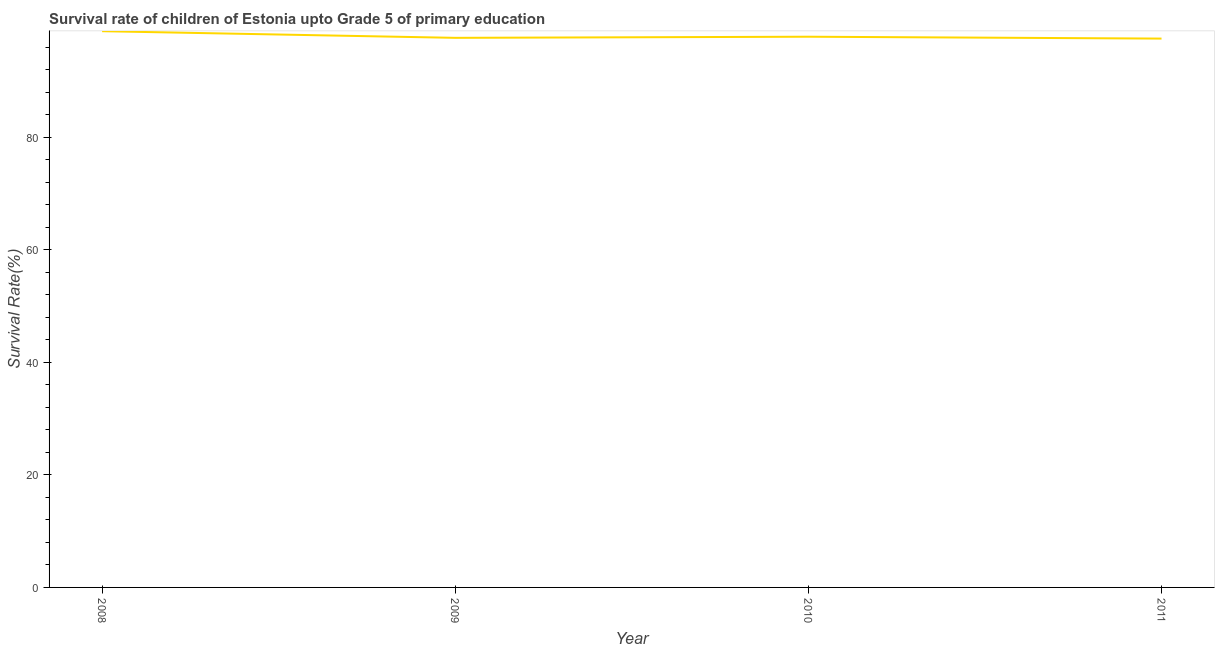What is the survival rate in 2010?
Give a very brief answer. 97.85. Across all years, what is the maximum survival rate?
Your answer should be compact. 98.83. Across all years, what is the minimum survival rate?
Provide a succinct answer. 97.52. In which year was the survival rate minimum?
Make the answer very short. 2011. What is the sum of the survival rate?
Make the answer very short. 391.84. What is the difference between the survival rate in 2008 and 2010?
Your answer should be compact. 0.98. What is the average survival rate per year?
Your answer should be very brief. 97.96. What is the median survival rate?
Your answer should be compact. 97.75. Do a majority of the years between 2011 and 2008 (inclusive) have survival rate greater than 72 %?
Give a very brief answer. Yes. What is the ratio of the survival rate in 2008 to that in 2010?
Ensure brevity in your answer.  1.01. Is the survival rate in 2008 less than that in 2009?
Provide a short and direct response. No. Is the difference between the survival rate in 2008 and 2011 greater than the difference between any two years?
Your answer should be very brief. Yes. What is the difference between the highest and the second highest survival rate?
Offer a terse response. 0.98. What is the difference between the highest and the lowest survival rate?
Offer a very short reply. 1.31. In how many years, is the survival rate greater than the average survival rate taken over all years?
Give a very brief answer. 1. Does the survival rate monotonically increase over the years?
Offer a very short reply. No. What is the difference between two consecutive major ticks on the Y-axis?
Your answer should be very brief. 20. Does the graph contain any zero values?
Ensure brevity in your answer.  No. What is the title of the graph?
Ensure brevity in your answer.  Survival rate of children of Estonia upto Grade 5 of primary education. What is the label or title of the Y-axis?
Your answer should be compact. Survival Rate(%). What is the Survival Rate(%) in 2008?
Provide a short and direct response. 98.83. What is the Survival Rate(%) in 2009?
Your answer should be compact. 97.65. What is the Survival Rate(%) in 2010?
Your answer should be compact. 97.85. What is the Survival Rate(%) of 2011?
Your response must be concise. 97.52. What is the difference between the Survival Rate(%) in 2008 and 2009?
Offer a very short reply. 1.18. What is the difference between the Survival Rate(%) in 2008 and 2010?
Provide a short and direct response. 0.98. What is the difference between the Survival Rate(%) in 2008 and 2011?
Ensure brevity in your answer.  1.31. What is the difference between the Survival Rate(%) in 2009 and 2010?
Your answer should be very brief. -0.2. What is the difference between the Survival Rate(%) in 2009 and 2011?
Give a very brief answer. 0.13. What is the difference between the Survival Rate(%) in 2010 and 2011?
Offer a terse response. 0.33. What is the ratio of the Survival Rate(%) in 2008 to that in 2010?
Your answer should be very brief. 1.01. What is the ratio of the Survival Rate(%) in 2008 to that in 2011?
Make the answer very short. 1.01. 